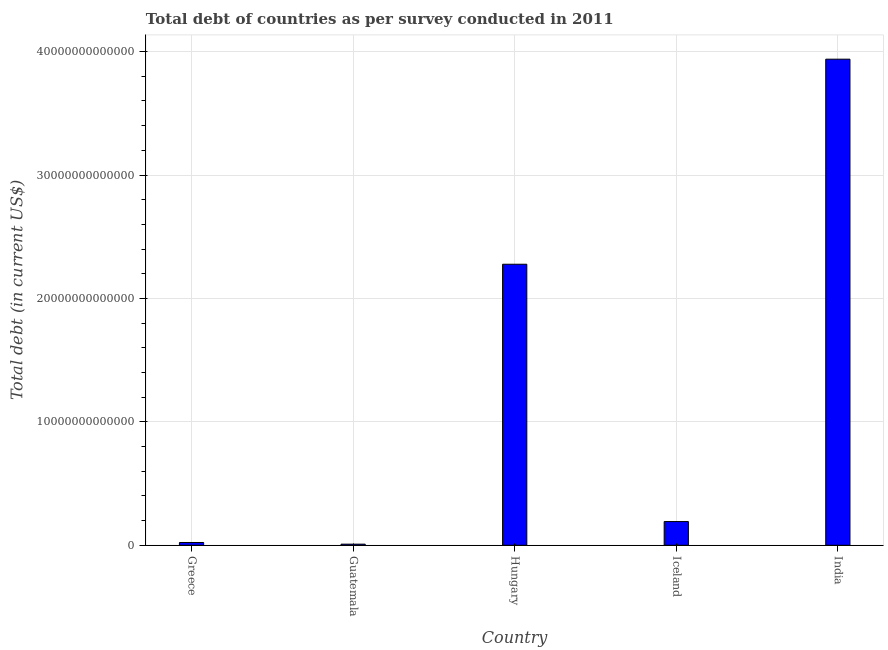Does the graph contain any zero values?
Give a very brief answer. No. Does the graph contain grids?
Offer a terse response. Yes. What is the title of the graph?
Offer a very short reply. Total debt of countries as per survey conducted in 2011. What is the label or title of the Y-axis?
Your answer should be very brief. Total debt (in current US$). What is the total debt in Guatemala?
Give a very brief answer. 8.96e+1. Across all countries, what is the maximum total debt?
Keep it short and to the point. 3.94e+13. Across all countries, what is the minimum total debt?
Make the answer very short. 8.96e+1. In which country was the total debt minimum?
Ensure brevity in your answer.  Guatemala. What is the sum of the total debt?
Keep it short and to the point. 6.44e+13. What is the difference between the total debt in Greece and Iceland?
Your answer should be compact. -1.70e+12. What is the average total debt per country?
Ensure brevity in your answer.  1.29e+13. What is the median total debt?
Provide a short and direct response. 1.92e+12. In how many countries, is the total debt greater than 28000000000000 US$?
Keep it short and to the point. 1. What is the ratio of the total debt in Guatemala to that in Iceland?
Provide a short and direct response. 0.05. Is the total debt in Greece less than that in Hungary?
Offer a very short reply. Yes. What is the difference between the highest and the second highest total debt?
Offer a terse response. 1.66e+13. What is the difference between the highest and the lowest total debt?
Offer a very short reply. 3.93e+13. In how many countries, is the total debt greater than the average total debt taken over all countries?
Your answer should be compact. 2. How many bars are there?
Your response must be concise. 5. Are all the bars in the graph horizontal?
Offer a very short reply. No. How many countries are there in the graph?
Provide a succinct answer. 5. What is the difference between two consecutive major ticks on the Y-axis?
Provide a succinct answer. 1.00e+13. What is the Total debt (in current US$) of Greece?
Provide a succinct answer. 2.26e+11. What is the Total debt (in current US$) in Guatemala?
Your response must be concise. 8.96e+1. What is the Total debt (in current US$) in Hungary?
Provide a succinct answer. 2.28e+13. What is the Total debt (in current US$) of Iceland?
Keep it short and to the point. 1.92e+12. What is the Total debt (in current US$) in India?
Your answer should be very brief. 3.94e+13. What is the difference between the Total debt (in current US$) in Greece and Guatemala?
Your answer should be very brief. 1.36e+11. What is the difference between the Total debt (in current US$) in Greece and Hungary?
Provide a short and direct response. -2.25e+13. What is the difference between the Total debt (in current US$) in Greece and Iceland?
Offer a terse response. -1.70e+12. What is the difference between the Total debt (in current US$) in Greece and India?
Keep it short and to the point. -3.92e+13. What is the difference between the Total debt (in current US$) in Guatemala and Hungary?
Your response must be concise. -2.27e+13. What is the difference between the Total debt (in current US$) in Guatemala and Iceland?
Offer a very short reply. -1.83e+12. What is the difference between the Total debt (in current US$) in Guatemala and India?
Ensure brevity in your answer.  -3.93e+13. What is the difference between the Total debt (in current US$) in Hungary and Iceland?
Offer a terse response. 2.08e+13. What is the difference between the Total debt (in current US$) in Hungary and India?
Provide a succinct answer. -1.66e+13. What is the difference between the Total debt (in current US$) in Iceland and India?
Provide a succinct answer. -3.75e+13. What is the ratio of the Total debt (in current US$) in Greece to that in Guatemala?
Your answer should be very brief. 2.52. What is the ratio of the Total debt (in current US$) in Greece to that in Iceland?
Provide a short and direct response. 0.12. What is the ratio of the Total debt (in current US$) in Greece to that in India?
Your answer should be compact. 0.01. What is the ratio of the Total debt (in current US$) in Guatemala to that in Hungary?
Ensure brevity in your answer.  0. What is the ratio of the Total debt (in current US$) in Guatemala to that in Iceland?
Give a very brief answer. 0.05. What is the ratio of the Total debt (in current US$) in Guatemala to that in India?
Your answer should be very brief. 0. What is the ratio of the Total debt (in current US$) in Hungary to that in Iceland?
Provide a short and direct response. 11.85. What is the ratio of the Total debt (in current US$) in Hungary to that in India?
Provide a short and direct response. 0.58. What is the ratio of the Total debt (in current US$) in Iceland to that in India?
Keep it short and to the point. 0.05. 